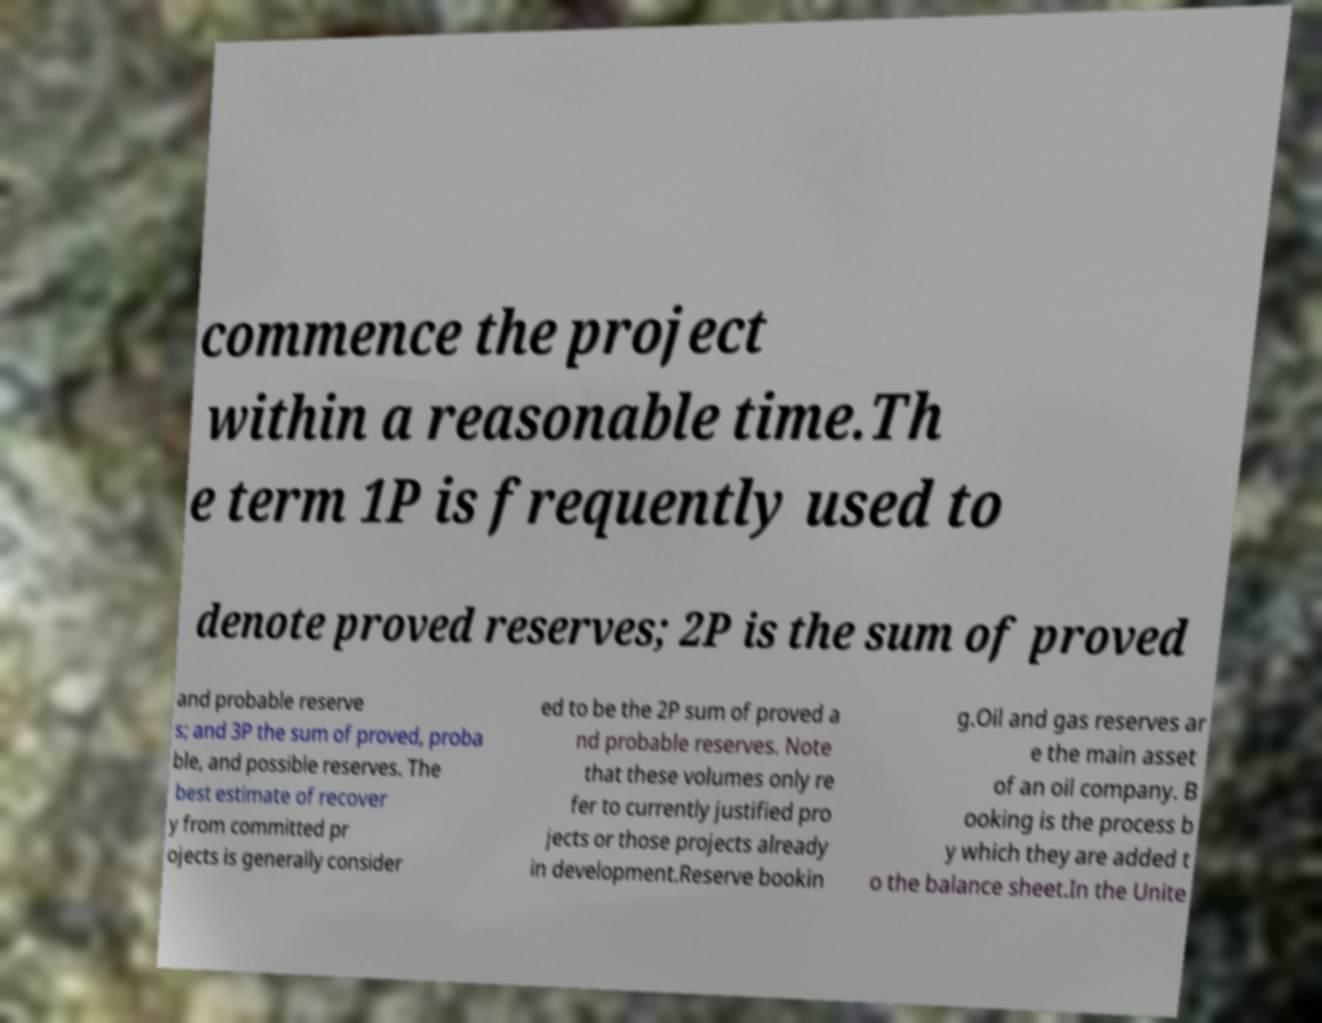What messages or text are displayed in this image? I need them in a readable, typed format. commence the project within a reasonable time.Th e term 1P is frequently used to denote proved reserves; 2P is the sum of proved and probable reserve s; and 3P the sum of proved, proba ble, and possible reserves. The best estimate of recover y from committed pr ojects is generally consider ed to be the 2P sum of proved a nd probable reserves. Note that these volumes only re fer to currently justified pro jects or those projects already in development.Reserve bookin g.Oil and gas reserves ar e the main asset of an oil company. B ooking is the process b y which they are added t o the balance sheet.In the Unite 